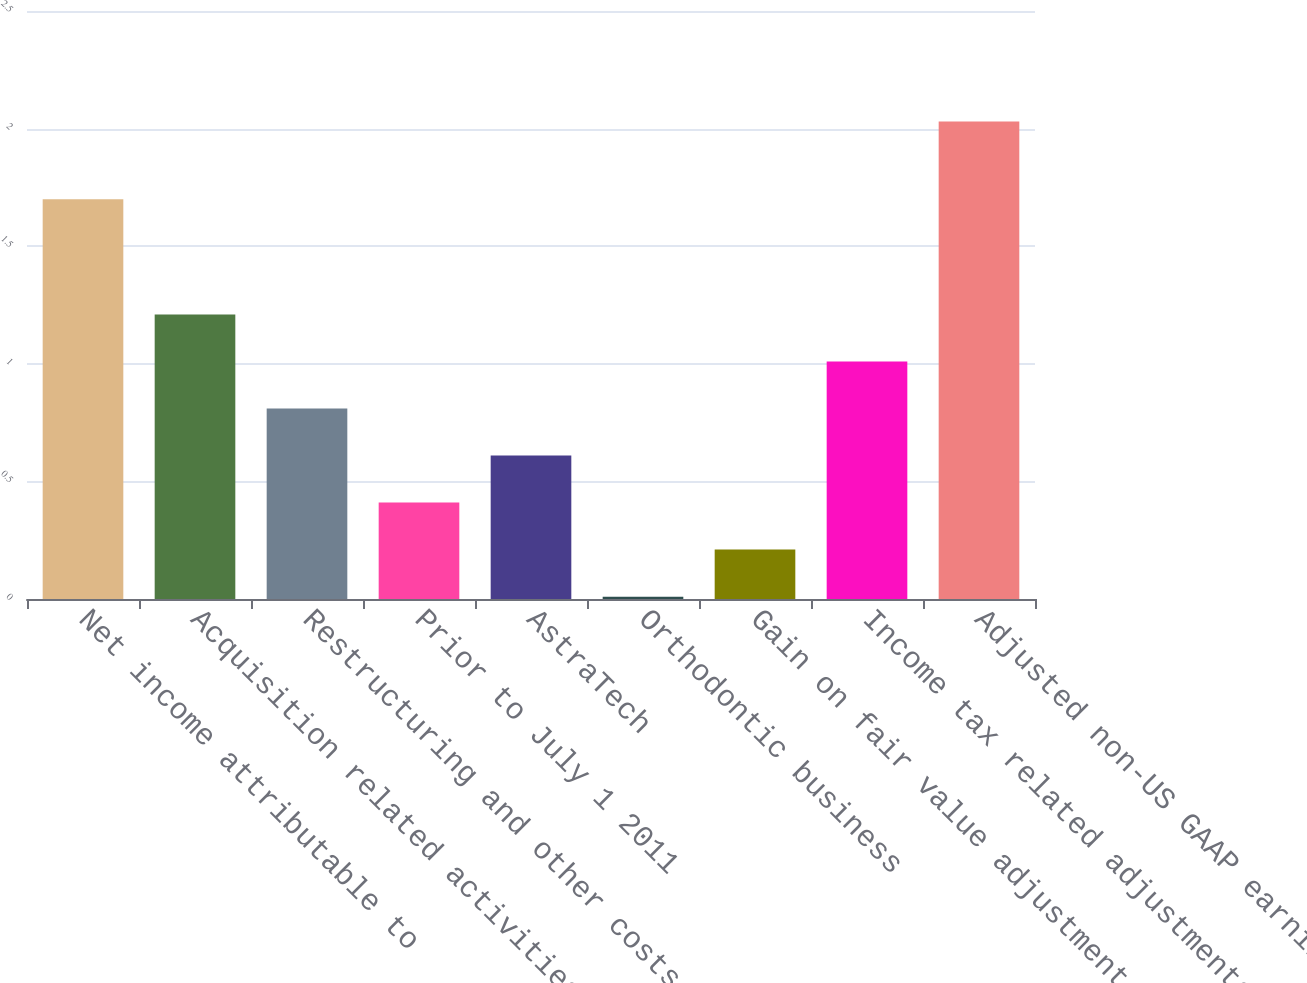Convert chart. <chart><loc_0><loc_0><loc_500><loc_500><bar_chart><fcel>Net income attributable to<fcel>Acquisition related activities<fcel>Restructuring and other costs<fcel>Prior to July 1 2011<fcel>AstraTech<fcel>Orthodontic business<fcel>Gain on fair value adjustment<fcel>Income tax related adjustments<fcel>Adjusted non-US GAAP earnings<nl><fcel>1.7<fcel>1.21<fcel>0.81<fcel>0.41<fcel>0.61<fcel>0.01<fcel>0.21<fcel>1.01<fcel>2.03<nl></chart> 